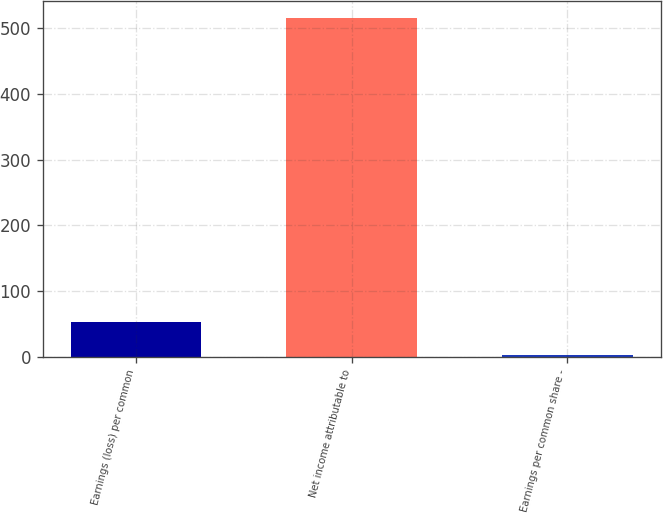Convert chart. <chart><loc_0><loc_0><loc_500><loc_500><bar_chart><fcel>Earnings (loss) per common<fcel>Net income attributable to<fcel>Earnings per common share -<nl><fcel>53.52<fcel>516<fcel>2.13<nl></chart> 